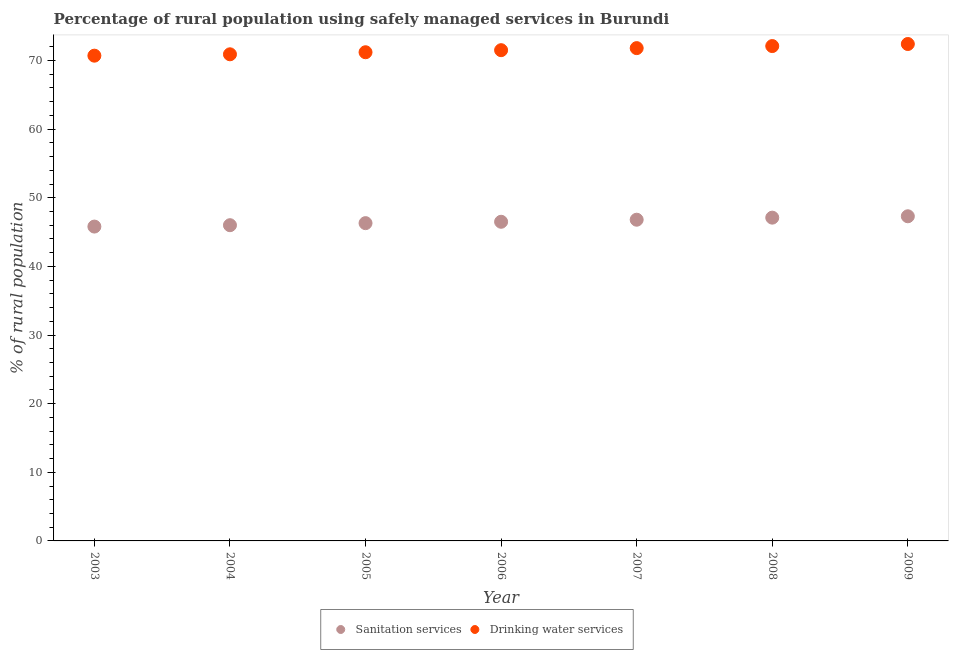Is the number of dotlines equal to the number of legend labels?
Your answer should be very brief. Yes. What is the percentage of rural population who used sanitation services in 2006?
Offer a terse response. 46.5. Across all years, what is the maximum percentage of rural population who used drinking water services?
Make the answer very short. 72.4. Across all years, what is the minimum percentage of rural population who used drinking water services?
Give a very brief answer. 70.7. In which year was the percentage of rural population who used drinking water services maximum?
Keep it short and to the point. 2009. In which year was the percentage of rural population who used sanitation services minimum?
Keep it short and to the point. 2003. What is the total percentage of rural population who used drinking water services in the graph?
Offer a very short reply. 500.6. What is the difference between the percentage of rural population who used sanitation services in 2006 and that in 2007?
Make the answer very short. -0.3. What is the difference between the percentage of rural population who used drinking water services in 2007 and the percentage of rural population who used sanitation services in 2006?
Provide a succinct answer. 25.3. What is the average percentage of rural population who used sanitation services per year?
Offer a very short reply. 46.54. In the year 2004, what is the difference between the percentage of rural population who used sanitation services and percentage of rural population who used drinking water services?
Your response must be concise. -24.9. What is the ratio of the percentage of rural population who used sanitation services in 2006 to that in 2008?
Give a very brief answer. 0.99. What is the difference between the highest and the second highest percentage of rural population who used sanitation services?
Your answer should be compact. 0.2. What is the difference between the highest and the lowest percentage of rural population who used sanitation services?
Your answer should be very brief. 1.5. In how many years, is the percentage of rural population who used drinking water services greater than the average percentage of rural population who used drinking water services taken over all years?
Make the answer very short. 3. Is the sum of the percentage of rural population who used sanitation services in 2003 and 2007 greater than the maximum percentage of rural population who used drinking water services across all years?
Give a very brief answer. Yes. Is the percentage of rural population who used sanitation services strictly greater than the percentage of rural population who used drinking water services over the years?
Offer a very short reply. No. Is the percentage of rural population who used sanitation services strictly less than the percentage of rural population who used drinking water services over the years?
Keep it short and to the point. Yes. How many dotlines are there?
Keep it short and to the point. 2. Are the values on the major ticks of Y-axis written in scientific E-notation?
Provide a short and direct response. No. Does the graph contain any zero values?
Give a very brief answer. No. Does the graph contain grids?
Offer a very short reply. No. Where does the legend appear in the graph?
Your answer should be compact. Bottom center. What is the title of the graph?
Give a very brief answer. Percentage of rural population using safely managed services in Burundi. What is the label or title of the X-axis?
Your answer should be very brief. Year. What is the label or title of the Y-axis?
Provide a succinct answer. % of rural population. What is the % of rural population in Sanitation services in 2003?
Give a very brief answer. 45.8. What is the % of rural population in Drinking water services in 2003?
Your answer should be very brief. 70.7. What is the % of rural population of Drinking water services in 2004?
Provide a short and direct response. 70.9. What is the % of rural population in Sanitation services in 2005?
Your response must be concise. 46.3. What is the % of rural population in Drinking water services in 2005?
Your answer should be compact. 71.2. What is the % of rural population of Sanitation services in 2006?
Provide a short and direct response. 46.5. What is the % of rural population of Drinking water services in 2006?
Your response must be concise. 71.5. What is the % of rural population of Sanitation services in 2007?
Keep it short and to the point. 46.8. What is the % of rural population of Drinking water services in 2007?
Provide a short and direct response. 71.8. What is the % of rural population of Sanitation services in 2008?
Your answer should be compact. 47.1. What is the % of rural population in Drinking water services in 2008?
Provide a short and direct response. 72.1. What is the % of rural population in Sanitation services in 2009?
Your answer should be very brief. 47.3. What is the % of rural population of Drinking water services in 2009?
Your answer should be compact. 72.4. Across all years, what is the maximum % of rural population in Sanitation services?
Provide a short and direct response. 47.3. Across all years, what is the maximum % of rural population in Drinking water services?
Ensure brevity in your answer.  72.4. Across all years, what is the minimum % of rural population of Sanitation services?
Your answer should be compact. 45.8. Across all years, what is the minimum % of rural population of Drinking water services?
Offer a very short reply. 70.7. What is the total % of rural population of Sanitation services in the graph?
Keep it short and to the point. 325.8. What is the total % of rural population of Drinking water services in the graph?
Ensure brevity in your answer.  500.6. What is the difference between the % of rural population of Sanitation services in 2003 and that in 2004?
Your answer should be very brief. -0.2. What is the difference between the % of rural population in Sanitation services in 2003 and that in 2007?
Your answer should be very brief. -1. What is the difference between the % of rural population of Sanitation services in 2003 and that in 2009?
Make the answer very short. -1.5. What is the difference between the % of rural population in Drinking water services in 2003 and that in 2009?
Your answer should be compact. -1.7. What is the difference between the % of rural population in Sanitation services in 2004 and that in 2005?
Provide a succinct answer. -0.3. What is the difference between the % of rural population in Drinking water services in 2004 and that in 2005?
Your answer should be compact. -0.3. What is the difference between the % of rural population in Sanitation services in 2004 and that in 2006?
Ensure brevity in your answer.  -0.5. What is the difference between the % of rural population in Drinking water services in 2004 and that in 2006?
Provide a short and direct response. -0.6. What is the difference between the % of rural population of Sanitation services in 2004 and that in 2007?
Keep it short and to the point. -0.8. What is the difference between the % of rural population of Drinking water services in 2004 and that in 2007?
Your response must be concise. -0.9. What is the difference between the % of rural population in Drinking water services in 2004 and that in 2008?
Your answer should be compact. -1.2. What is the difference between the % of rural population in Sanitation services in 2004 and that in 2009?
Make the answer very short. -1.3. What is the difference between the % of rural population in Sanitation services in 2005 and that in 2006?
Your answer should be very brief. -0.2. What is the difference between the % of rural population in Sanitation services in 2006 and that in 2007?
Your answer should be compact. -0.3. What is the difference between the % of rural population in Sanitation services in 2006 and that in 2008?
Offer a terse response. -0.6. What is the difference between the % of rural population of Sanitation services in 2006 and that in 2009?
Keep it short and to the point. -0.8. What is the difference between the % of rural population of Sanitation services in 2008 and that in 2009?
Your answer should be compact. -0.2. What is the difference between the % of rural population of Sanitation services in 2003 and the % of rural population of Drinking water services in 2004?
Keep it short and to the point. -25.1. What is the difference between the % of rural population of Sanitation services in 2003 and the % of rural population of Drinking water services in 2005?
Provide a short and direct response. -25.4. What is the difference between the % of rural population in Sanitation services in 2003 and the % of rural population in Drinking water services in 2006?
Offer a very short reply. -25.7. What is the difference between the % of rural population in Sanitation services in 2003 and the % of rural population in Drinking water services in 2008?
Provide a short and direct response. -26.3. What is the difference between the % of rural population in Sanitation services in 2003 and the % of rural population in Drinking water services in 2009?
Your answer should be very brief. -26.6. What is the difference between the % of rural population in Sanitation services in 2004 and the % of rural population in Drinking water services in 2005?
Your response must be concise. -25.2. What is the difference between the % of rural population of Sanitation services in 2004 and the % of rural population of Drinking water services in 2006?
Offer a terse response. -25.5. What is the difference between the % of rural population in Sanitation services in 2004 and the % of rural population in Drinking water services in 2007?
Your answer should be compact. -25.8. What is the difference between the % of rural population in Sanitation services in 2004 and the % of rural population in Drinking water services in 2008?
Offer a terse response. -26.1. What is the difference between the % of rural population of Sanitation services in 2004 and the % of rural population of Drinking water services in 2009?
Offer a terse response. -26.4. What is the difference between the % of rural population of Sanitation services in 2005 and the % of rural population of Drinking water services in 2006?
Ensure brevity in your answer.  -25.2. What is the difference between the % of rural population in Sanitation services in 2005 and the % of rural population in Drinking water services in 2007?
Your answer should be compact. -25.5. What is the difference between the % of rural population in Sanitation services in 2005 and the % of rural population in Drinking water services in 2008?
Your answer should be very brief. -25.8. What is the difference between the % of rural population of Sanitation services in 2005 and the % of rural population of Drinking water services in 2009?
Make the answer very short. -26.1. What is the difference between the % of rural population of Sanitation services in 2006 and the % of rural population of Drinking water services in 2007?
Offer a very short reply. -25.3. What is the difference between the % of rural population in Sanitation services in 2006 and the % of rural population in Drinking water services in 2008?
Provide a short and direct response. -25.6. What is the difference between the % of rural population in Sanitation services in 2006 and the % of rural population in Drinking water services in 2009?
Your answer should be compact. -25.9. What is the difference between the % of rural population of Sanitation services in 2007 and the % of rural population of Drinking water services in 2008?
Provide a short and direct response. -25.3. What is the difference between the % of rural population of Sanitation services in 2007 and the % of rural population of Drinking water services in 2009?
Your answer should be very brief. -25.6. What is the difference between the % of rural population in Sanitation services in 2008 and the % of rural population in Drinking water services in 2009?
Provide a succinct answer. -25.3. What is the average % of rural population in Sanitation services per year?
Provide a succinct answer. 46.54. What is the average % of rural population in Drinking water services per year?
Your answer should be compact. 71.51. In the year 2003, what is the difference between the % of rural population in Sanitation services and % of rural population in Drinking water services?
Offer a terse response. -24.9. In the year 2004, what is the difference between the % of rural population of Sanitation services and % of rural population of Drinking water services?
Give a very brief answer. -24.9. In the year 2005, what is the difference between the % of rural population in Sanitation services and % of rural population in Drinking water services?
Provide a succinct answer. -24.9. In the year 2006, what is the difference between the % of rural population of Sanitation services and % of rural population of Drinking water services?
Make the answer very short. -25. In the year 2009, what is the difference between the % of rural population in Sanitation services and % of rural population in Drinking water services?
Your answer should be very brief. -25.1. What is the ratio of the % of rural population in Sanitation services in 2003 to that in 2004?
Offer a very short reply. 1. What is the ratio of the % of rural population of Drinking water services in 2003 to that in 2004?
Offer a very short reply. 1. What is the ratio of the % of rural population in Drinking water services in 2003 to that in 2005?
Ensure brevity in your answer.  0.99. What is the ratio of the % of rural population of Sanitation services in 2003 to that in 2006?
Make the answer very short. 0.98. What is the ratio of the % of rural population of Drinking water services in 2003 to that in 2006?
Provide a succinct answer. 0.99. What is the ratio of the % of rural population of Sanitation services in 2003 to that in 2007?
Your response must be concise. 0.98. What is the ratio of the % of rural population in Drinking water services in 2003 to that in 2007?
Offer a terse response. 0.98. What is the ratio of the % of rural population of Sanitation services in 2003 to that in 2008?
Your response must be concise. 0.97. What is the ratio of the % of rural population of Drinking water services in 2003 to that in 2008?
Your answer should be compact. 0.98. What is the ratio of the % of rural population of Sanitation services in 2003 to that in 2009?
Keep it short and to the point. 0.97. What is the ratio of the % of rural population in Drinking water services in 2003 to that in 2009?
Your response must be concise. 0.98. What is the ratio of the % of rural population in Sanitation services in 2004 to that in 2006?
Offer a terse response. 0.99. What is the ratio of the % of rural population in Drinking water services in 2004 to that in 2006?
Offer a terse response. 0.99. What is the ratio of the % of rural population in Sanitation services in 2004 to that in 2007?
Ensure brevity in your answer.  0.98. What is the ratio of the % of rural population in Drinking water services in 2004 to that in 2007?
Ensure brevity in your answer.  0.99. What is the ratio of the % of rural population in Sanitation services in 2004 to that in 2008?
Provide a succinct answer. 0.98. What is the ratio of the % of rural population of Drinking water services in 2004 to that in 2008?
Your answer should be compact. 0.98. What is the ratio of the % of rural population in Sanitation services in 2004 to that in 2009?
Ensure brevity in your answer.  0.97. What is the ratio of the % of rural population in Drinking water services in 2004 to that in 2009?
Give a very brief answer. 0.98. What is the ratio of the % of rural population of Drinking water services in 2005 to that in 2006?
Make the answer very short. 1. What is the ratio of the % of rural population of Sanitation services in 2005 to that in 2007?
Give a very brief answer. 0.99. What is the ratio of the % of rural population of Drinking water services in 2005 to that in 2007?
Your answer should be very brief. 0.99. What is the ratio of the % of rural population in Sanitation services in 2005 to that in 2008?
Offer a terse response. 0.98. What is the ratio of the % of rural population in Drinking water services in 2005 to that in 2008?
Ensure brevity in your answer.  0.99. What is the ratio of the % of rural population of Sanitation services in 2005 to that in 2009?
Keep it short and to the point. 0.98. What is the ratio of the % of rural population in Drinking water services in 2005 to that in 2009?
Keep it short and to the point. 0.98. What is the ratio of the % of rural population in Sanitation services in 2006 to that in 2007?
Offer a terse response. 0.99. What is the ratio of the % of rural population of Sanitation services in 2006 to that in 2008?
Provide a succinct answer. 0.99. What is the ratio of the % of rural population in Sanitation services in 2006 to that in 2009?
Your answer should be compact. 0.98. What is the ratio of the % of rural population in Drinking water services in 2006 to that in 2009?
Ensure brevity in your answer.  0.99. What is the ratio of the % of rural population of Drinking water services in 2007 to that in 2008?
Your answer should be compact. 1. What is the ratio of the % of rural population of Sanitation services in 2007 to that in 2009?
Make the answer very short. 0.99. What is the ratio of the % of rural population in Sanitation services in 2008 to that in 2009?
Make the answer very short. 1. What is the difference between the highest and the second highest % of rural population of Sanitation services?
Make the answer very short. 0.2. What is the difference between the highest and the second highest % of rural population in Drinking water services?
Your response must be concise. 0.3. 